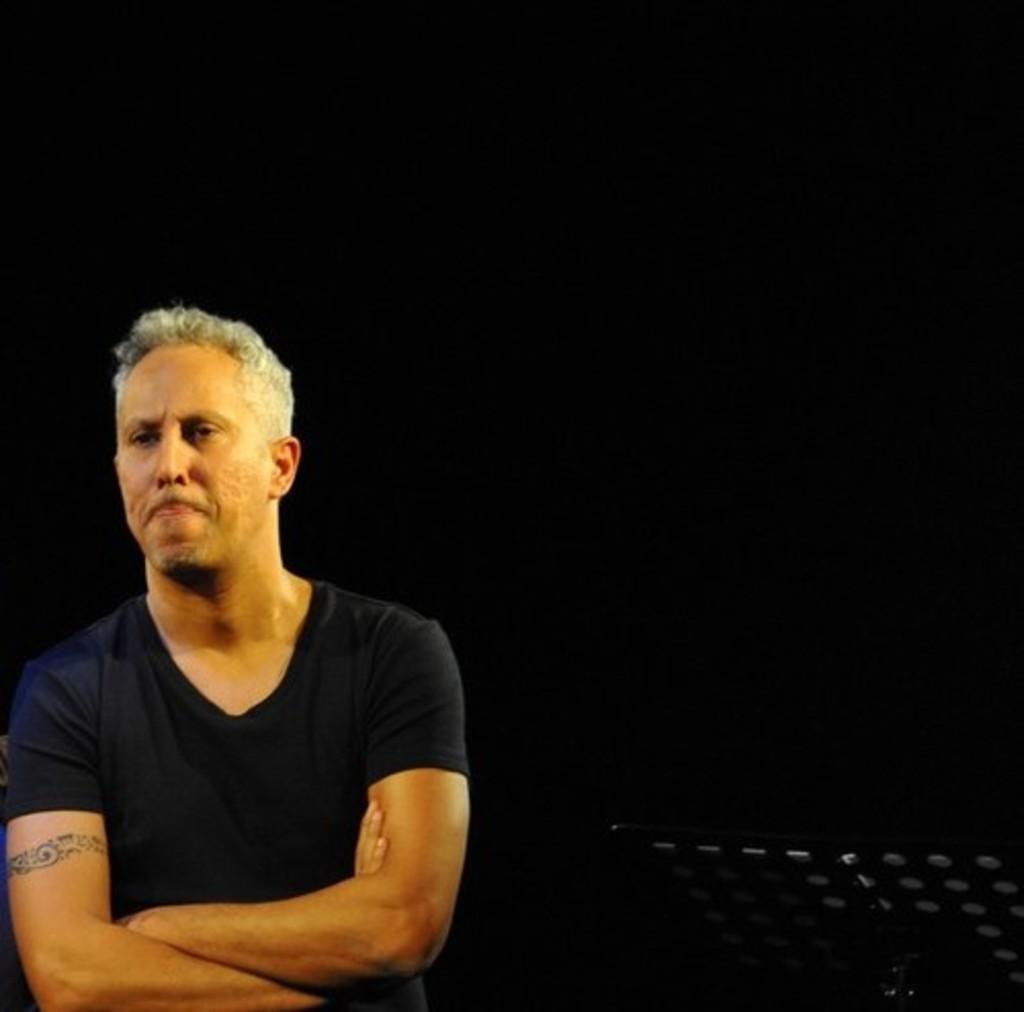Please provide a concise description of this image. In this image there is a man standing. There is a tattoo on his arm. Behind him it is dark. 